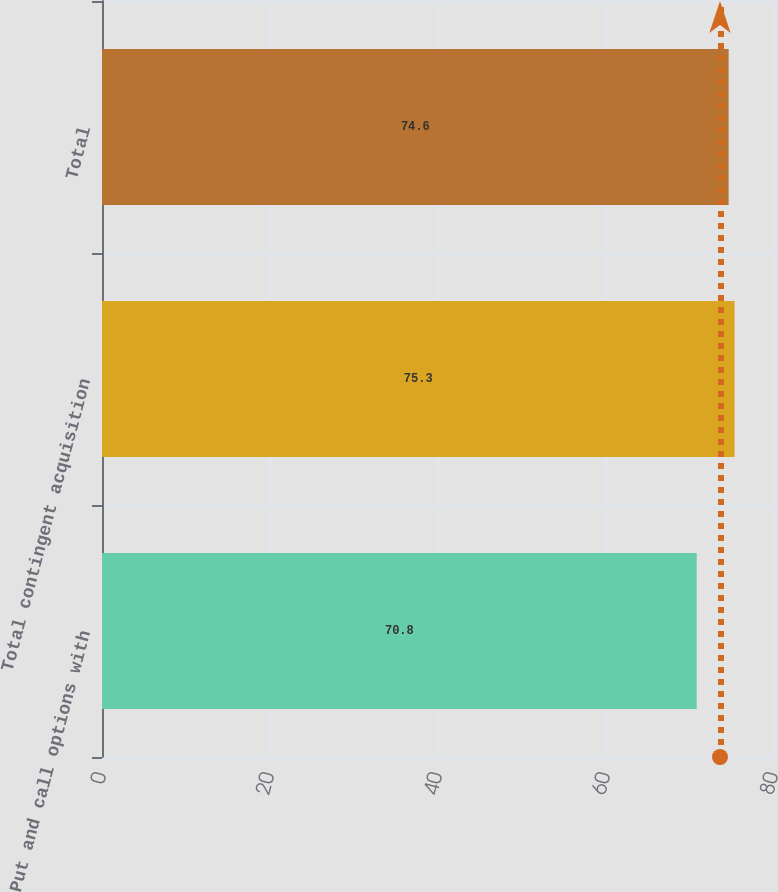<chart> <loc_0><loc_0><loc_500><loc_500><bar_chart><fcel>Put and call options with<fcel>Total contingent acquisition<fcel>Total<nl><fcel>70.8<fcel>75.3<fcel>74.6<nl></chart> 